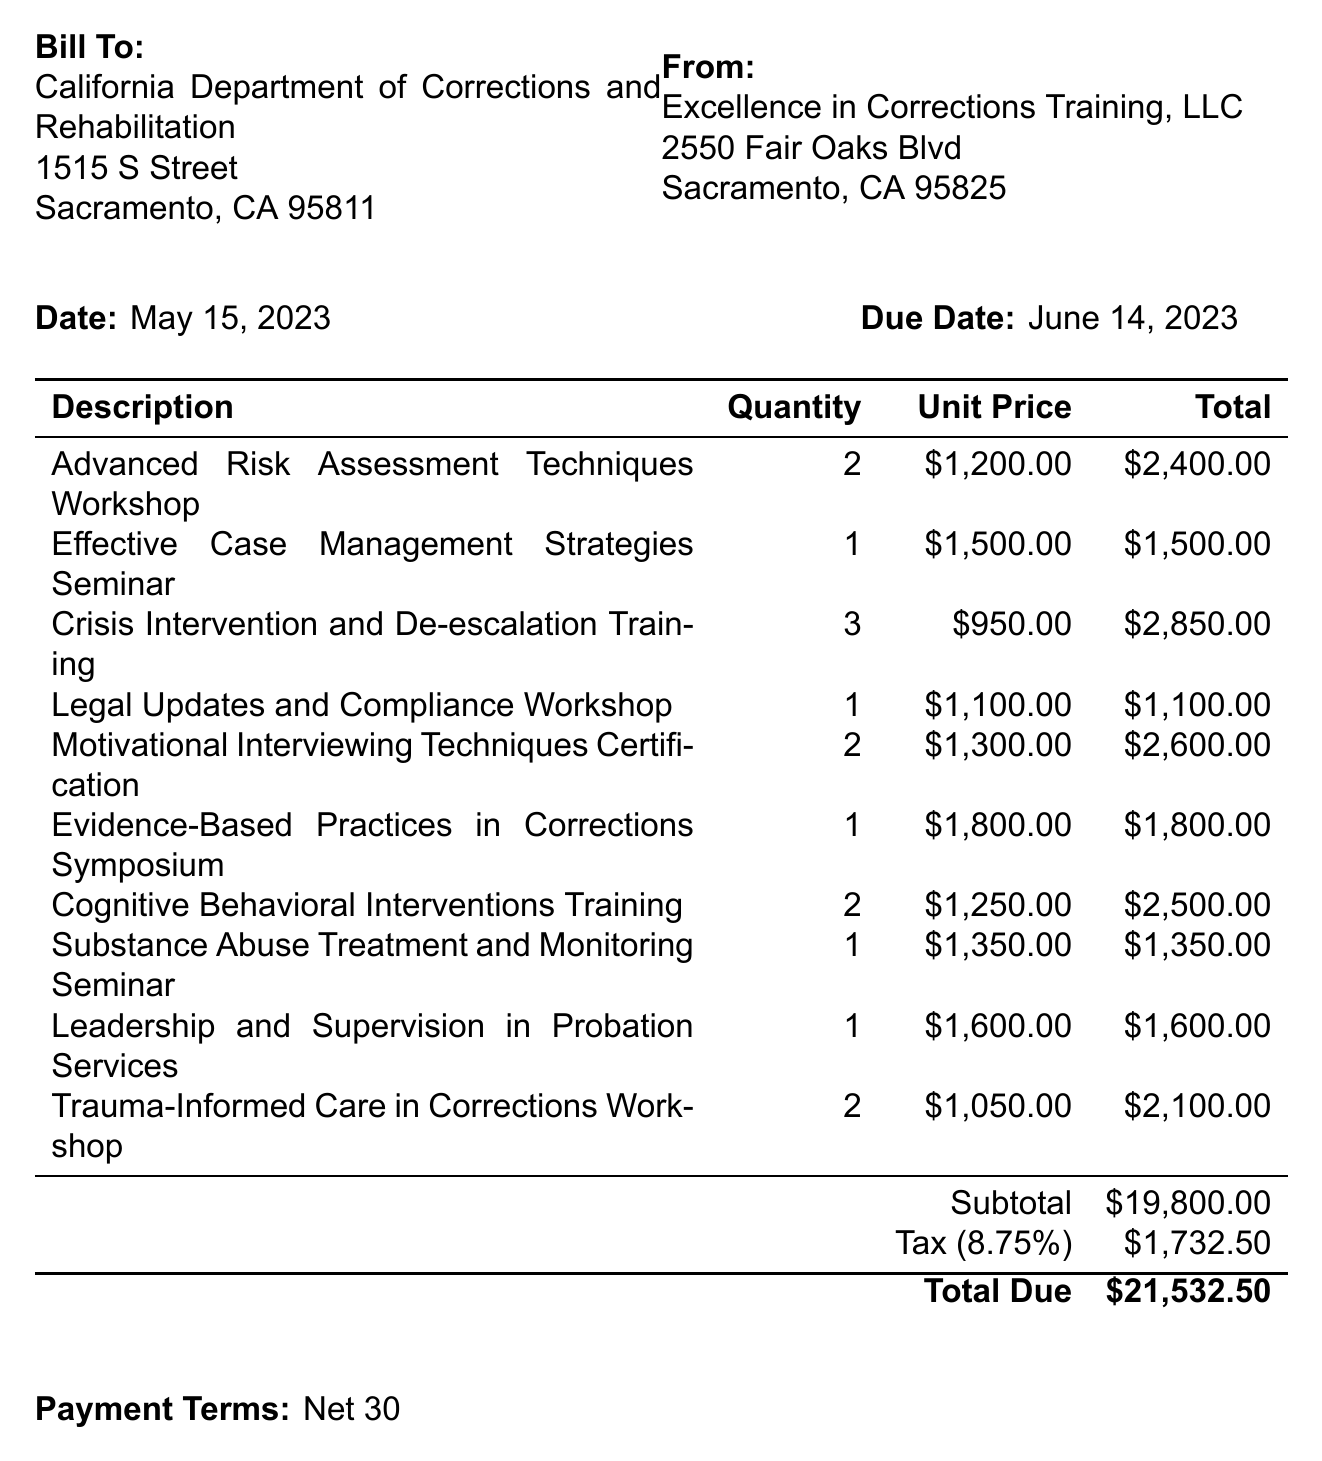What is the invoice number? The invoice number is specified in the header of the document, indicating the unique identifier for this invoice.
Answer: PO-2023-0542 What is the due date for payment? The due date is presented clearly in the document, indicating when the payment must be made.
Answer: June 14, 2023 Who is billed on this invoice? The "Bill To" section specifies the organization being billed for the services provided.
Answer: California Department of Corrections and Rehabilitation What is the subtotal amount before tax? The subtotal is the total cost of the line items before any taxes are applied, as stated in the document.
Answer: $19,800.00 How many workshops are listed in total? The total number of workshops can be determined by counting the line items in the document.
Answer: 10 What is the total amount due including tax? Total due is the final amount to be paid, including subtotal and tax, as shown at the bottom of the invoice.
Answer: $21,532.50 What is the payment term specified in this invoice? The payment terms indicate the timeline for when payment is expected after the invoice date.
Answer: Net 30 Is attendance at the workshops mandatory? The notes section mentions the nature of attendance, specifying requirements for probation staff.
Answer: Yes What is the tax rate applied to this invoice? The tax rate is mentioned with the tax amount, providing clarity on the percentage applied to the subtotal.
Answer: 8.75% 